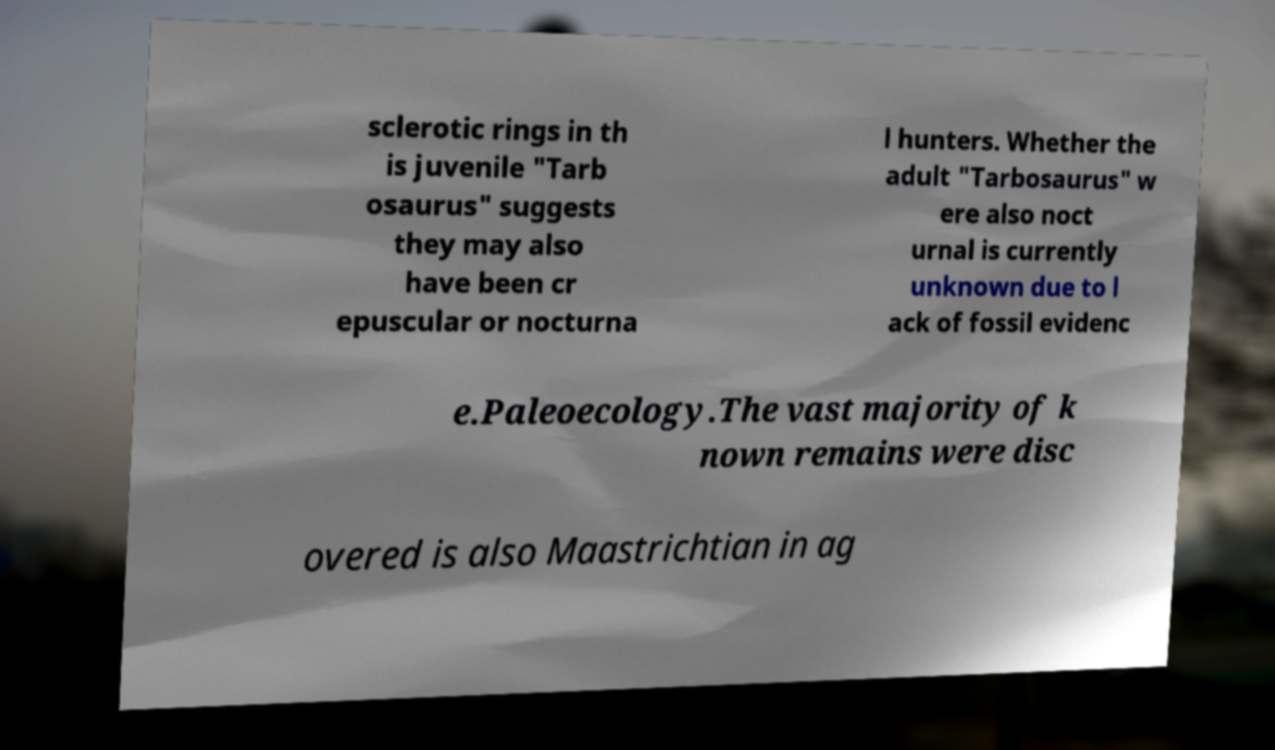I need the written content from this picture converted into text. Can you do that? sclerotic rings in th is juvenile "Tarb osaurus" suggests they may also have been cr epuscular or nocturna l hunters. Whether the adult "Tarbosaurus" w ere also noct urnal is currently unknown due to l ack of fossil evidenc e.Paleoecology.The vast majority of k nown remains were disc overed is also Maastrichtian in ag 